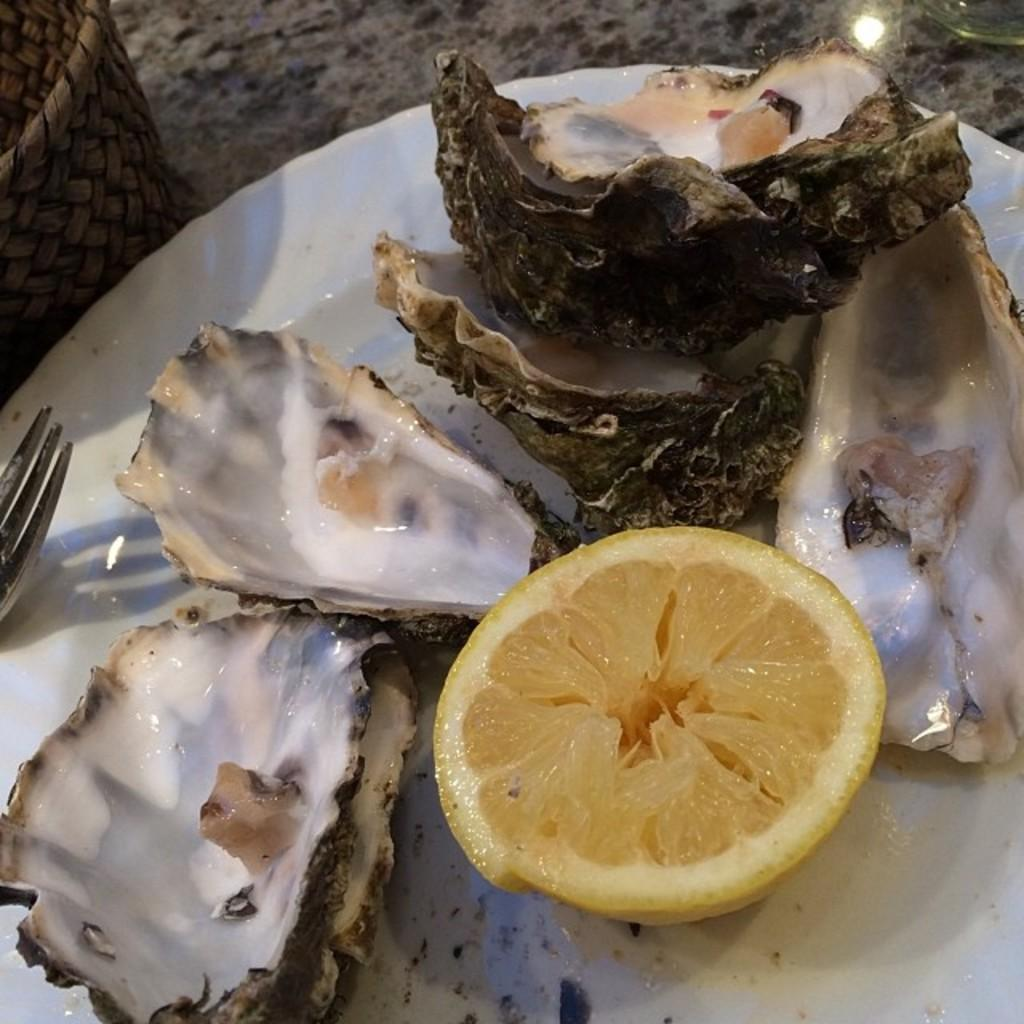What is on the plate that is visible in the image? The plate contains shell fishes and a lemon. What utensil is located near the plate in the image? There is a fork on the left side of the plate. What is beside the plate in the image? There is a basket beside the plate. What type of riddle can be solved using the shell fishes in the image? There is no riddle present in the image, and the shell fishes are not associated with any riddle. 